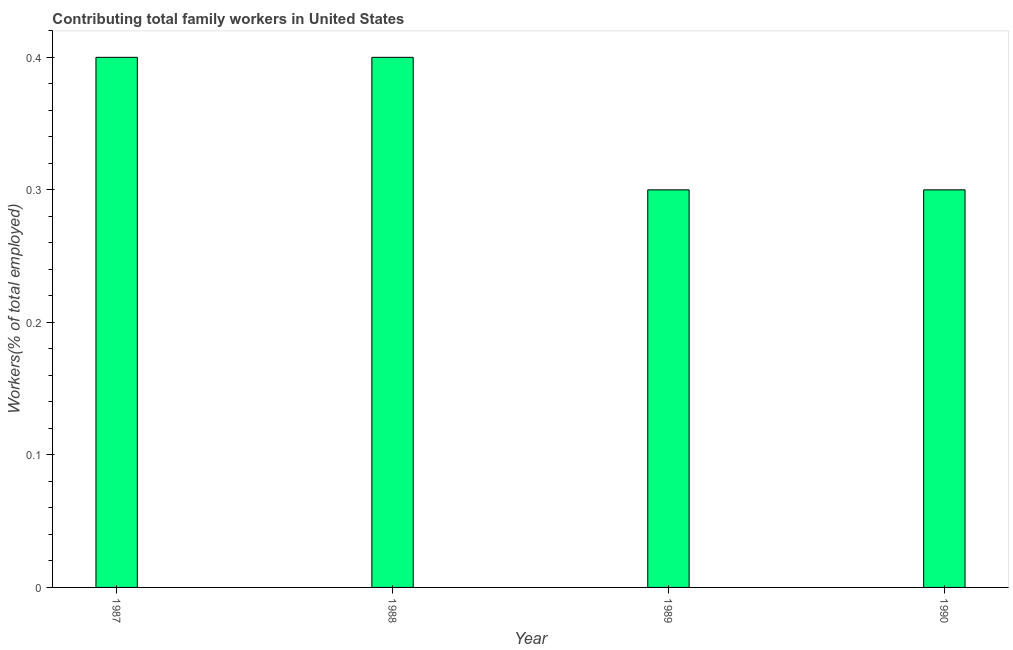What is the title of the graph?
Provide a short and direct response. Contributing total family workers in United States. What is the label or title of the Y-axis?
Your response must be concise. Workers(% of total employed). What is the contributing family workers in 1988?
Your response must be concise. 0.4. Across all years, what is the maximum contributing family workers?
Keep it short and to the point. 0.4. Across all years, what is the minimum contributing family workers?
Give a very brief answer. 0.3. In which year was the contributing family workers minimum?
Make the answer very short. 1989. What is the sum of the contributing family workers?
Make the answer very short. 1.4. What is the difference between the contributing family workers in 1988 and 1990?
Provide a short and direct response. 0.1. What is the average contributing family workers per year?
Ensure brevity in your answer.  0.35. What is the median contributing family workers?
Offer a very short reply. 0.35. What is the ratio of the contributing family workers in 1987 to that in 1988?
Make the answer very short. 1. Is the difference between the contributing family workers in 1988 and 1989 greater than the difference between any two years?
Ensure brevity in your answer.  Yes. Is the sum of the contributing family workers in 1988 and 1989 greater than the maximum contributing family workers across all years?
Offer a terse response. Yes. What is the difference between the highest and the lowest contributing family workers?
Your response must be concise. 0.1. In how many years, is the contributing family workers greater than the average contributing family workers taken over all years?
Give a very brief answer. 2. How many years are there in the graph?
Provide a succinct answer. 4. What is the difference between two consecutive major ticks on the Y-axis?
Your answer should be very brief. 0.1. Are the values on the major ticks of Y-axis written in scientific E-notation?
Provide a succinct answer. No. What is the Workers(% of total employed) in 1987?
Give a very brief answer. 0.4. What is the Workers(% of total employed) of 1988?
Ensure brevity in your answer.  0.4. What is the Workers(% of total employed) in 1989?
Provide a short and direct response. 0.3. What is the Workers(% of total employed) of 1990?
Offer a terse response. 0.3. What is the difference between the Workers(% of total employed) in 1987 and 1989?
Offer a terse response. 0.1. What is the difference between the Workers(% of total employed) in 1987 and 1990?
Ensure brevity in your answer.  0.1. What is the difference between the Workers(% of total employed) in 1988 and 1989?
Offer a very short reply. 0.1. What is the difference between the Workers(% of total employed) in 1989 and 1990?
Give a very brief answer. 0. What is the ratio of the Workers(% of total employed) in 1987 to that in 1988?
Your answer should be very brief. 1. What is the ratio of the Workers(% of total employed) in 1987 to that in 1989?
Your answer should be very brief. 1.33. What is the ratio of the Workers(% of total employed) in 1987 to that in 1990?
Offer a very short reply. 1.33. What is the ratio of the Workers(% of total employed) in 1988 to that in 1989?
Keep it short and to the point. 1.33. What is the ratio of the Workers(% of total employed) in 1988 to that in 1990?
Give a very brief answer. 1.33. What is the ratio of the Workers(% of total employed) in 1989 to that in 1990?
Give a very brief answer. 1. 